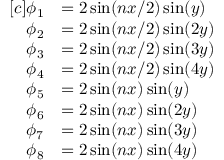<formula> <loc_0><loc_0><loc_500><loc_500>\begin{array} { r l } { [ c ] \phi _ { 1 } } & { = 2 \sin ( n x / 2 ) \sin ( y ) } \\ { \phi _ { 2 } } & { = 2 \sin ( n x / 2 ) \sin ( 2 y ) } \\ { \phi _ { 3 } } & { = 2 \sin ( n x / 2 ) \sin ( 3 y ) } \\ { \phi _ { 4 } } & { = 2 \sin ( n x / 2 ) \sin ( 4 y ) } \\ { \phi _ { 5 } } & { = 2 \sin ( n x ) \sin ( y ) } \\ { \phi _ { 6 } } & { = 2 \sin ( n x ) \sin ( 2 y ) } \\ { \phi _ { 7 } } & { = 2 \sin ( n x ) \sin ( 3 y ) } \\ { \phi _ { 8 } } & { = 2 \sin ( n x ) \sin ( 4 y ) } \end{array}</formula> 